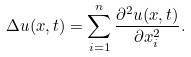<formula> <loc_0><loc_0><loc_500><loc_500>\Delta u ( x , t ) = \sum _ { i = 1 } ^ { n } \frac { \partial ^ { 2 } u ( x , t ) } { \partial x _ { i } ^ { 2 } } .</formula> 